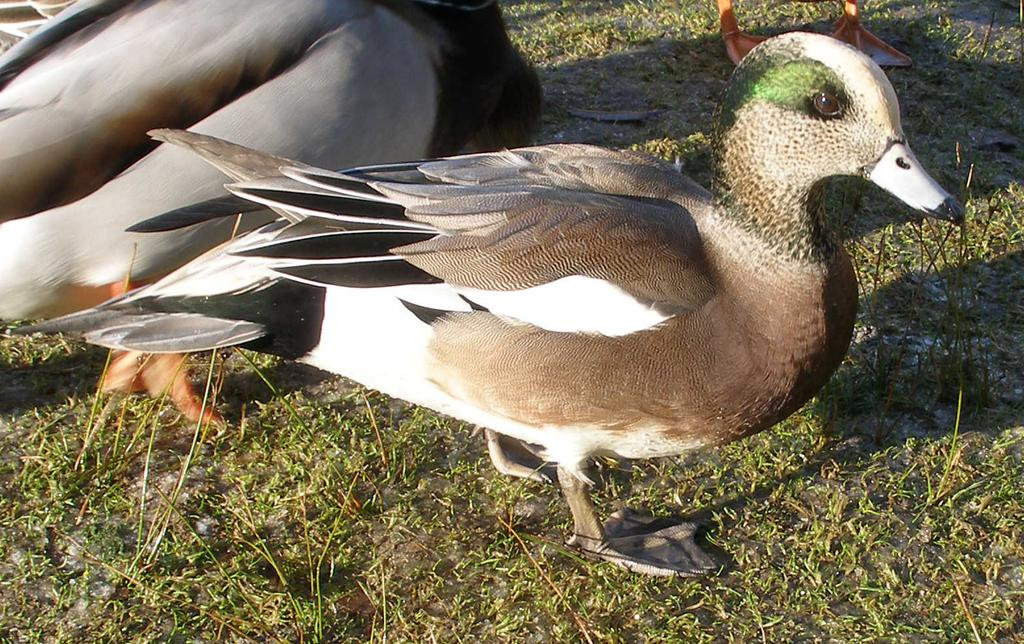What type of animals are present in the image? There are ducks in the image. What colors can be seen among the ducks? The ducks are white, brown, black, and green in color. What type of vegetation is visible in the image? There is grass visible in the image. What type of fish can be seen swimming in the image? There are no fish present in the image; it features ducks and grass. What design can be seen on the ducks' feathers in the image? The facts provided do not mention any specific design on the ducks' feathers, so we cannot answer this question. 